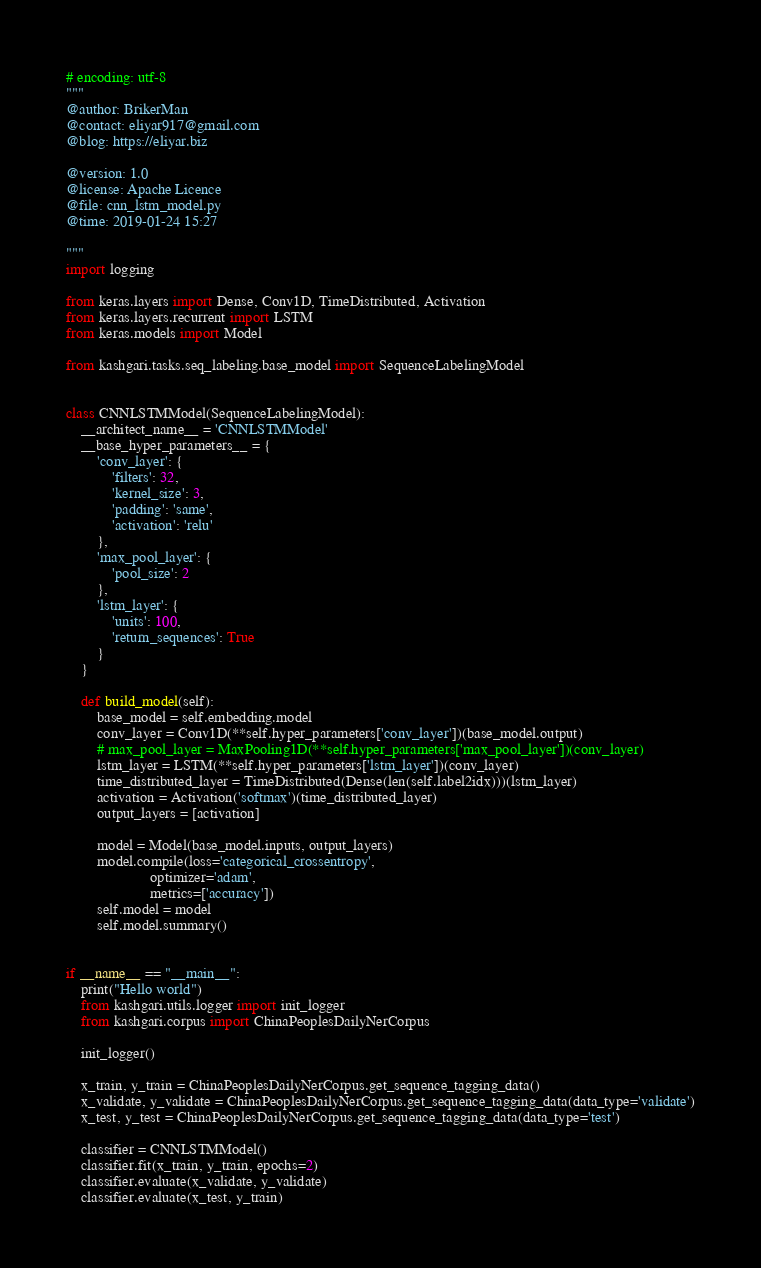<code> <loc_0><loc_0><loc_500><loc_500><_Python_># encoding: utf-8
"""
@author: BrikerMan
@contact: eliyar917@gmail.com
@blog: https://eliyar.biz

@version: 1.0
@license: Apache Licence
@file: cnn_lstm_model.py
@time: 2019-01-24 15:27

"""
import logging

from keras.layers import Dense, Conv1D, TimeDistributed, Activation
from keras.layers.recurrent import LSTM
from keras.models import Model

from kashgari.tasks.seq_labeling.base_model import SequenceLabelingModel


class CNNLSTMModel(SequenceLabelingModel):
    __architect_name__ = 'CNNLSTMModel'
    __base_hyper_parameters__ = {
        'conv_layer': {
            'filters': 32,
            'kernel_size': 3,
            'padding': 'same',
            'activation': 'relu'
        },
        'max_pool_layer': {
            'pool_size': 2
        },
        'lstm_layer': {
            'units': 100,
            'return_sequences': True
        }
    }

    def build_model(self):
        base_model = self.embedding.model
        conv_layer = Conv1D(**self.hyper_parameters['conv_layer'])(base_model.output)
        # max_pool_layer = MaxPooling1D(**self.hyper_parameters['max_pool_layer'])(conv_layer)
        lstm_layer = LSTM(**self.hyper_parameters['lstm_layer'])(conv_layer)
        time_distributed_layer = TimeDistributed(Dense(len(self.label2idx)))(lstm_layer)
        activation = Activation('softmax')(time_distributed_layer)
        output_layers = [activation]

        model = Model(base_model.inputs, output_layers)
        model.compile(loss='categorical_crossentropy',
                      optimizer='adam',
                      metrics=['accuracy'])
        self.model = model
        self.model.summary()


if __name__ == "__main__":
    print("Hello world")
    from kashgari.utils.logger import init_logger
    from kashgari.corpus import ChinaPeoplesDailyNerCorpus

    init_logger()

    x_train, y_train = ChinaPeoplesDailyNerCorpus.get_sequence_tagging_data()
    x_validate, y_validate = ChinaPeoplesDailyNerCorpus.get_sequence_tagging_data(data_type='validate')
    x_test, y_test = ChinaPeoplesDailyNerCorpus.get_sequence_tagging_data(data_type='test')

    classifier = CNNLSTMModel()
    classifier.fit(x_train, y_train, epochs=2)
    classifier.evaluate(x_validate, y_validate)
    classifier.evaluate(x_test, y_train)
</code> 